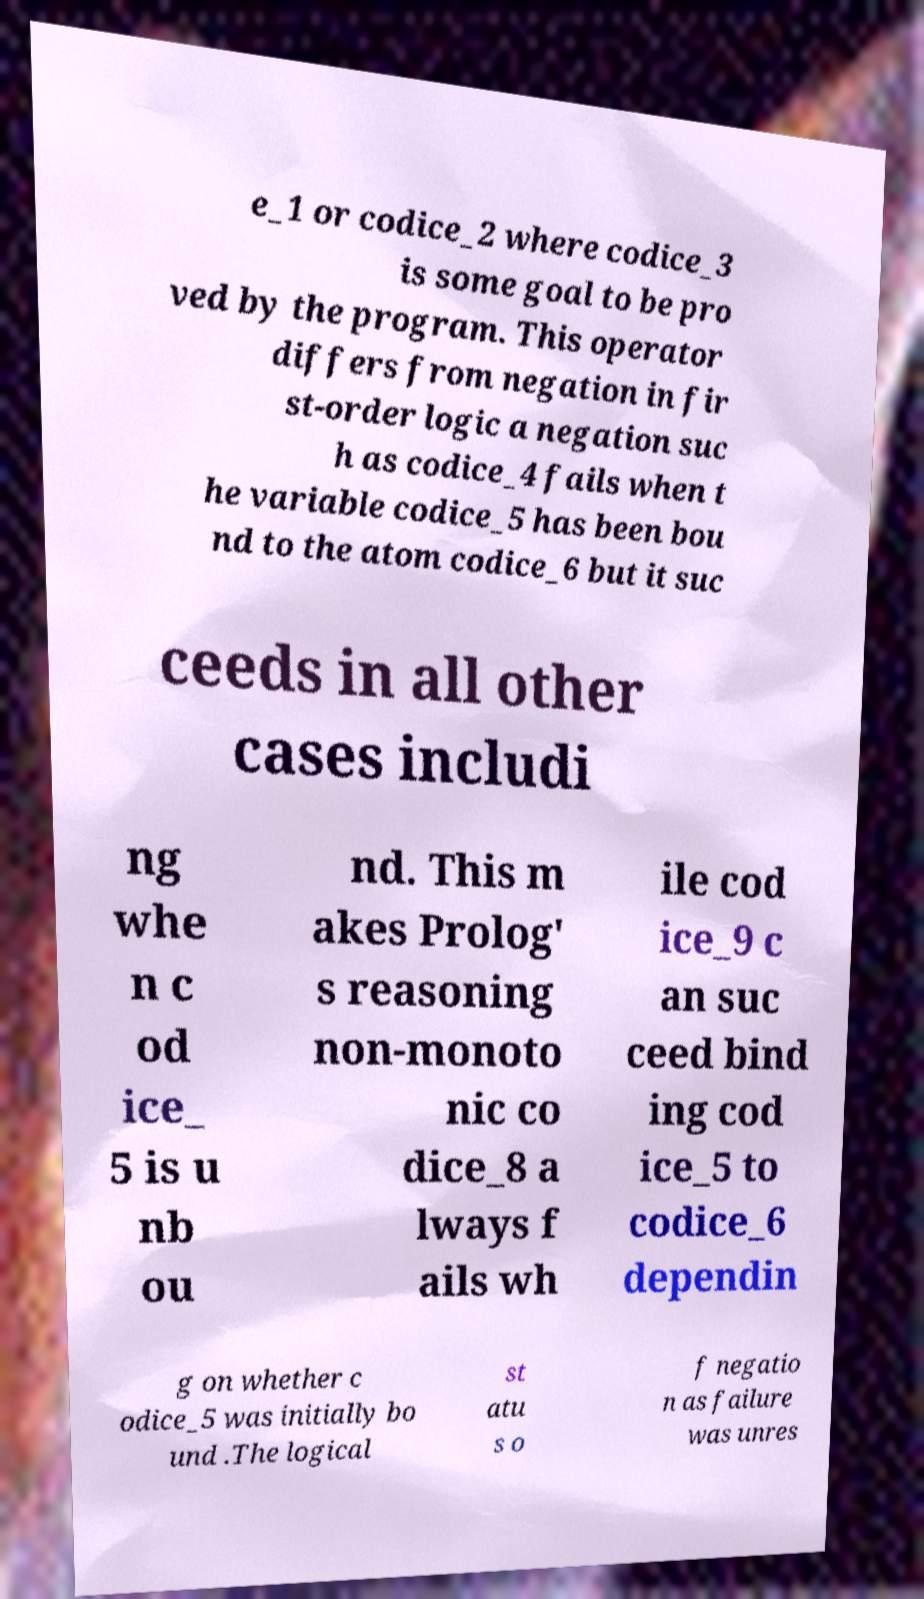For documentation purposes, I need the text within this image transcribed. Could you provide that? e_1 or codice_2 where codice_3 is some goal to be pro ved by the program. This operator differs from negation in fir st-order logic a negation suc h as codice_4 fails when t he variable codice_5 has been bou nd to the atom codice_6 but it suc ceeds in all other cases includi ng whe n c od ice_ 5 is u nb ou nd. This m akes Prolog' s reasoning non-monoto nic co dice_8 a lways f ails wh ile cod ice_9 c an suc ceed bind ing cod ice_5 to codice_6 dependin g on whether c odice_5 was initially bo und .The logical st atu s o f negatio n as failure was unres 